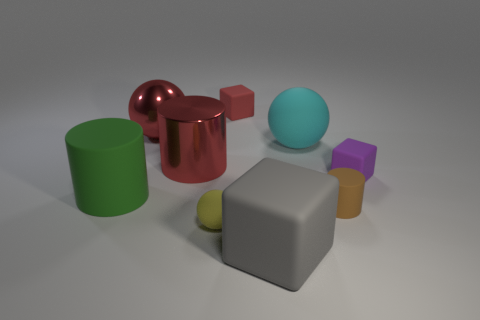Do the small brown cylinder and the purple thing right of the gray rubber thing have the same material?
Your answer should be very brief. Yes. How many things are either big red metal cubes or rubber blocks that are behind the large metal cylinder?
Offer a terse response. 1. Is the size of the rubber cube behind the large cyan rubber object the same as the rubber sphere to the right of the red matte object?
Keep it short and to the point. No. What number of other things are the same color as the large rubber cube?
Provide a short and direct response. 0. There is a purple matte block; is it the same size as the thing that is in front of the yellow ball?
Give a very brief answer. No. There is a matte ball left of the tiny matte block behind the purple matte block; how big is it?
Offer a very short reply. Small. The other big rubber thing that is the same shape as the brown matte thing is what color?
Give a very brief answer. Green. Is the size of the red cylinder the same as the yellow matte ball?
Your response must be concise. No. Is the number of cylinders on the right side of the large cube the same as the number of gray matte cubes?
Provide a short and direct response. Yes. There is a rubber cylinder that is left of the tiny brown matte object; is there a tiny brown rubber cylinder that is to the left of it?
Offer a very short reply. No. 